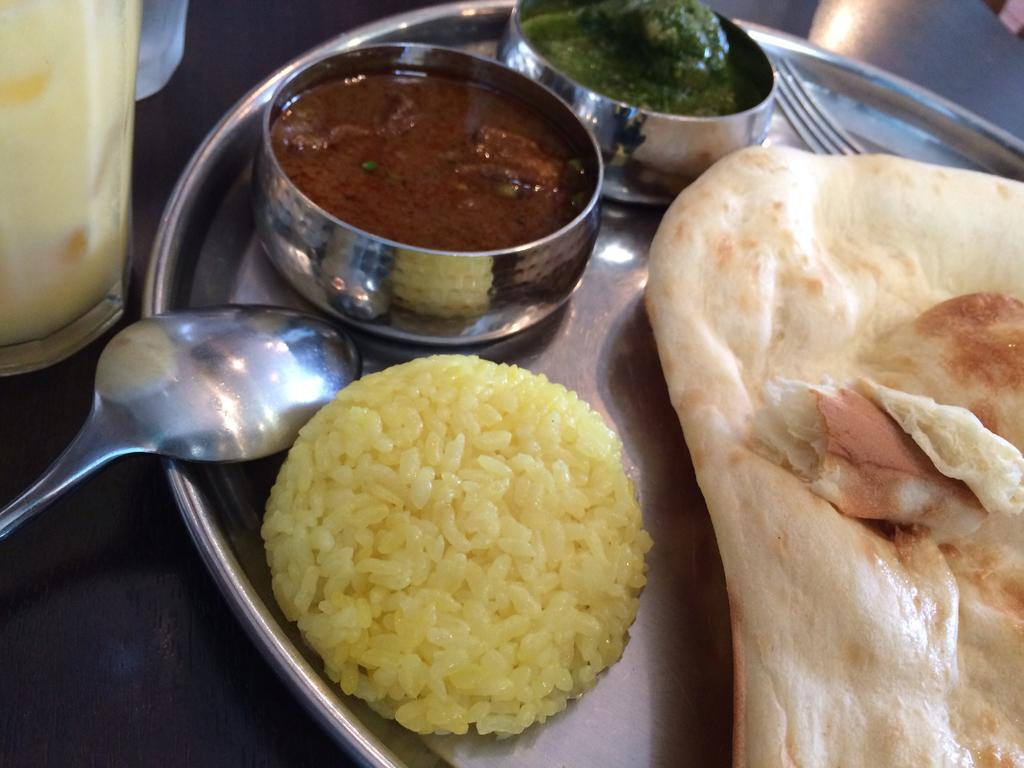What type of utensils can be seen in the image? There are food spoons and forks in the image. What is used to serve food in the image? There is a plate in the image. What is located on the left side of the image? There is a glass on the left side of the image. How many chairs are visible in the image? There are no chairs present in the image. What type of agricultural equipment can be seen in the image? There is no agricultural equipment, such as a plough, present in the image. 